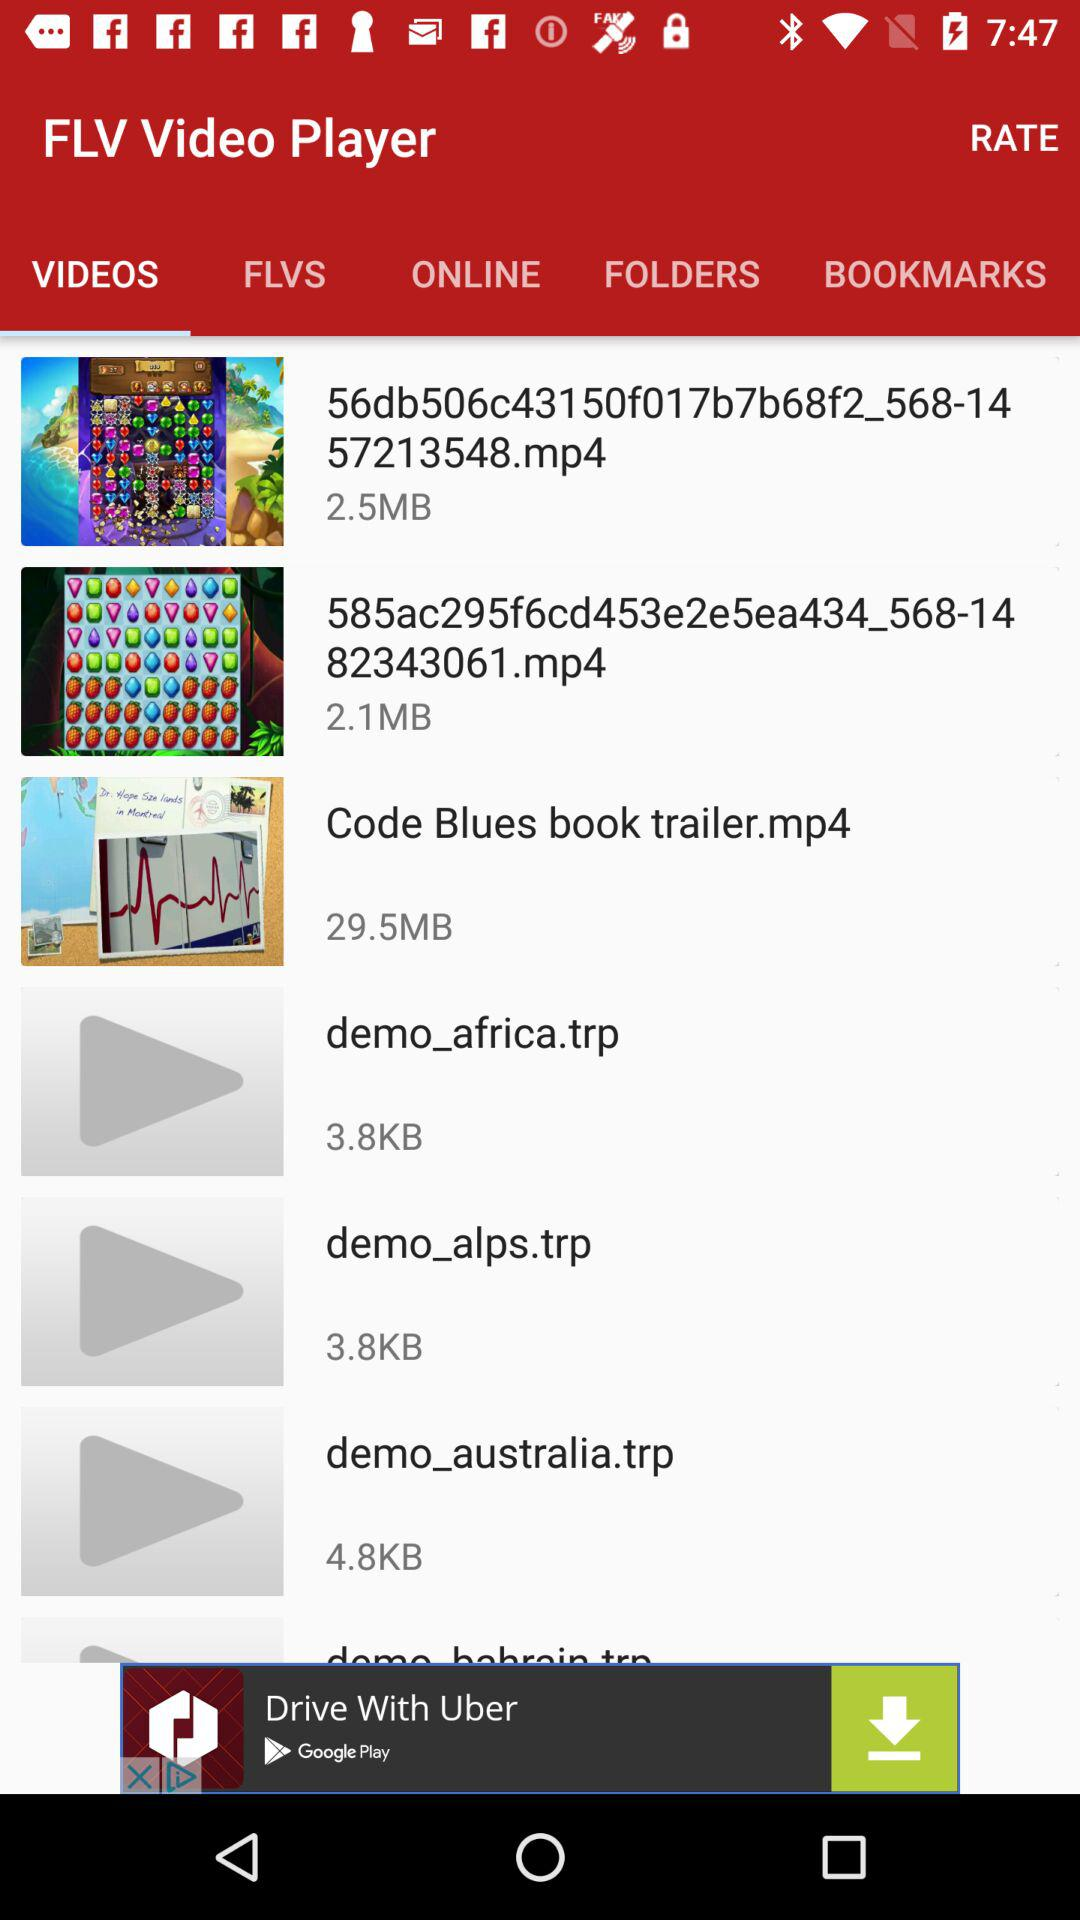What is the size of "demo_australia.trp"? The size is 4.8 KB. 